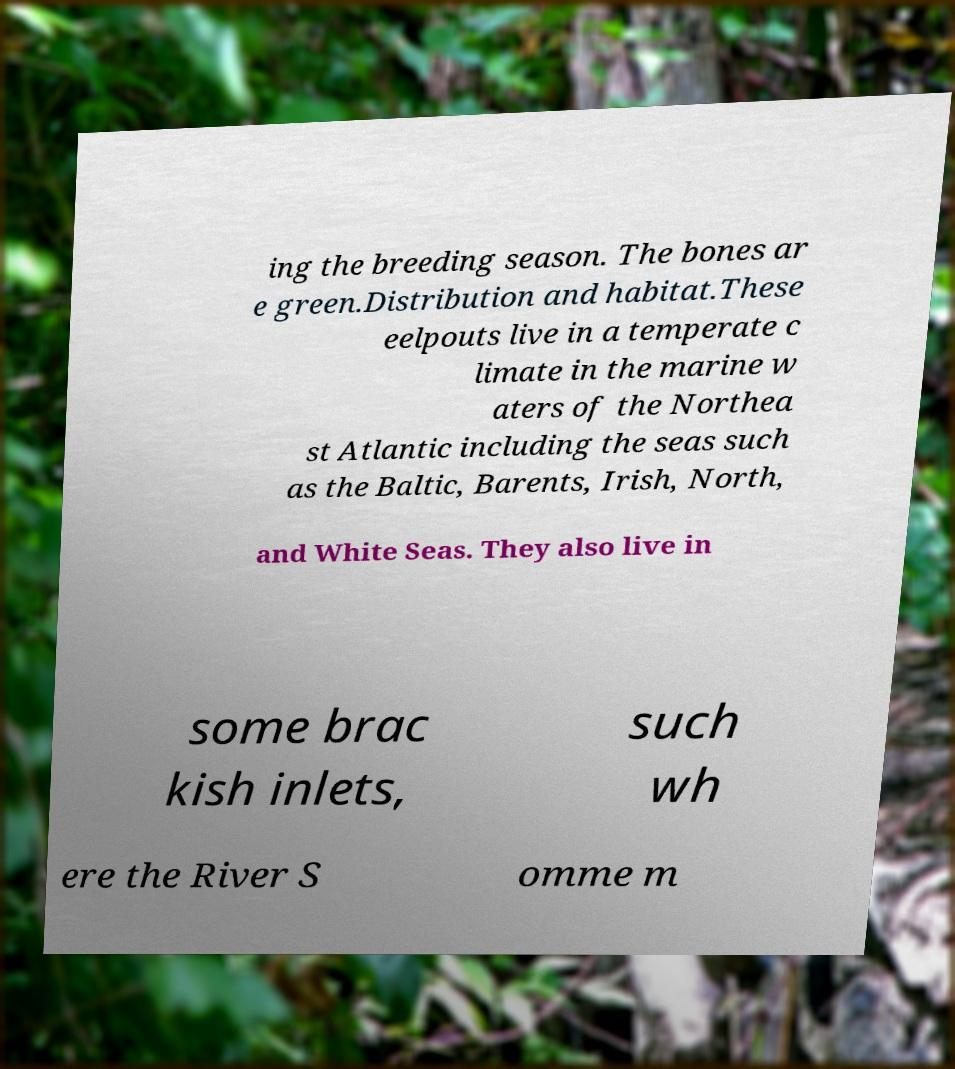Can you read and provide the text displayed in the image?This photo seems to have some interesting text. Can you extract and type it out for me? ing the breeding season. The bones ar e green.Distribution and habitat.These eelpouts live in a temperate c limate in the marine w aters of the Northea st Atlantic including the seas such as the Baltic, Barents, Irish, North, and White Seas. They also live in some brac kish inlets, such wh ere the River S omme m 